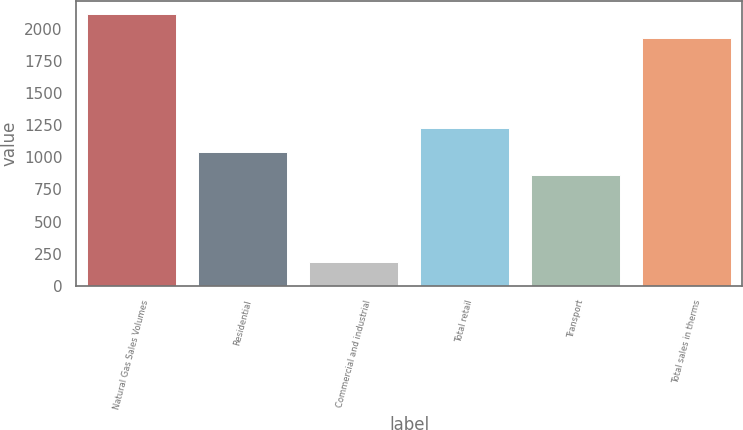Convert chart to OTSL. <chart><loc_0><loc_0><loc_500><loc_500><bar_chart><fcel>Natural Gas Sales Volumes<fcel>Residential<fcel>Commercial and industrial<fcel>Total retail<fcel>Transport<fcel>Total sales in therms<nl><fcel>2111.94<fcel>1042.14<fcel>183.6<fcel>1225.48<fcel>858.8<fcel>1928.6<nl></chart> 